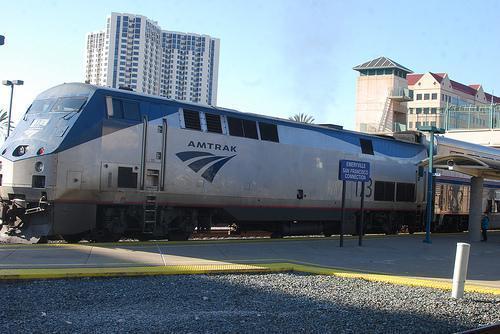How many trains are there?
Give a very brief answer. 1. 